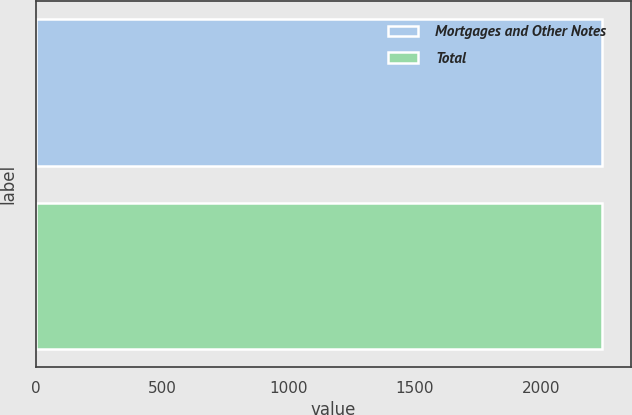<chart> <loc_0><loc_0><loc_500><loc_500><bar_chart><fcel>Mortgages and Other Notes<fcel>Total<nl><fcel>2241<fcel>2241.1<nl></chart> 